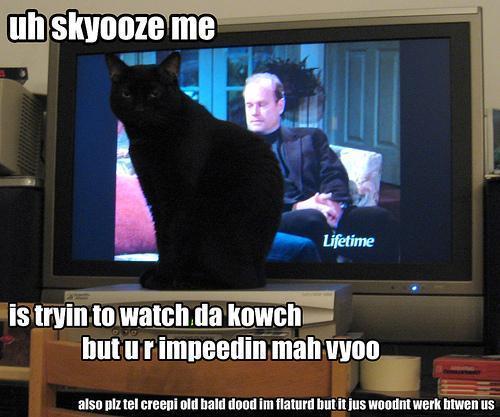How many televisions are shown?
Give a very brief answer. 1. 